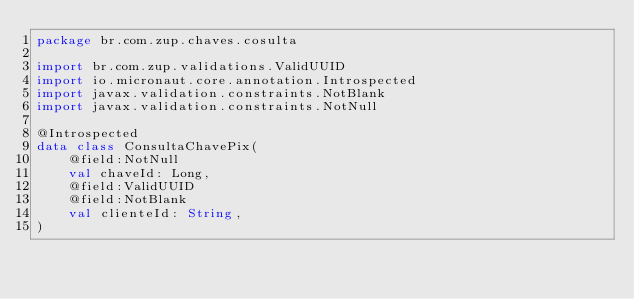Convert code to text. <code><loc_0><loc_0><loc_500><loc_500><_Kotlin_>package br.com.zup.chaves.cosulta

import br.com.zup.validations.ValidUUID
import io.micronaut.core.annotation.Introspected
import javax.validation.constraints.NotBlank
import javax.validation.constraints.NotNull

@Introspected
data class ConsultaChavePix(
    @field:NotNull
    val chaveId: Long,
    @field:ValidUUID
    @field:NotBlank
    val clienteId: String,
)</code> 